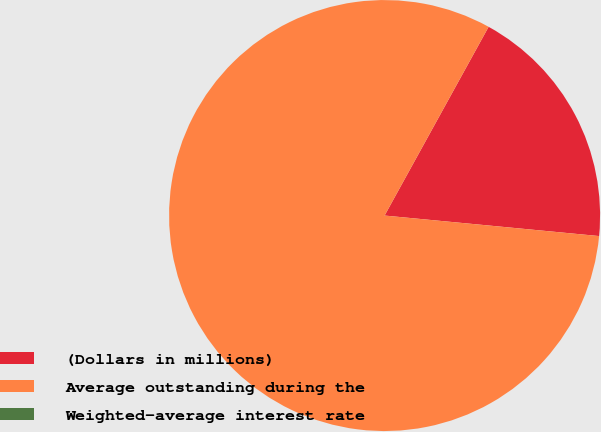Convert chart to OTSL. <chart><loc_0><loc_0><loc_500><loc_500><pie_chart><fcel>(Dollars in millions)<fcel>Average outstanding during the<fcel>Weighted-average interest rate<nl><fcel>18.5%<fcel>81.5%<fcel>0.0%<nl></chart> 